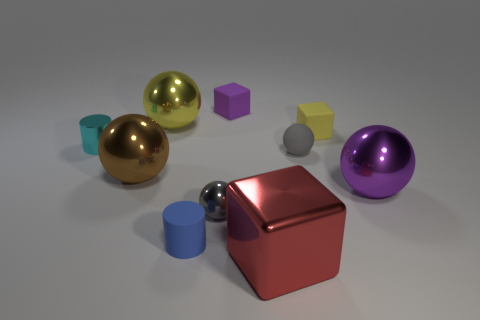Subtract all green cubes. How many gray balls are left? 2 Subtract all large red shiny cubes. How many cubes are left? 2 Subtract all gray balls. How many balls are left? 3 Subtract 2 spheres. How many spheres are left? 3 Subtract all red spheres. Subtract all green cubes. How many spheres are left? 5 Subtract all cylinders. How many objects are left? 8 Add 8 gray matte spheres. How many gray matte spheres are left? 9 Add 2 small things. How many small things exist? 8 Subtract 1 yellow blocks. How many objects are left? 9 Subtract all purple objects. Subtract all gray metallic things. How many objects are left? 7 